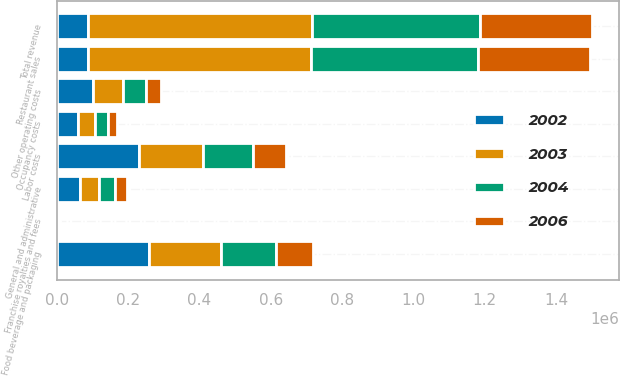Convert chart to OTSL. <chart><loc_0><loc_0><loc_500><loc_500><stacked_bar_chart><ecel><fcel>Restaurant sales<fcel>Franchise royalties and fees<fcel>Total revenue<fcel>Food beverage and packaging<fcel>Labor costs<fcel>Occupancy costs<fcel>Other operating costs<fcel>General and administrative<nl><fcel>2002<fcel>88499.5<fcel>3143<fcel>88499.5<fcel>257998<fcel>231134<fcel>58804<fcel>102745<fcel>65284<nl><fcel>2003<fcel>625077<fcel>2618<fcel>627695<fcel>202288<fcel>178721<fcel>47636<fcel>82976<fcel>51964<nl><fcel>2004<fcel>468579<fcel>2142<fcel>470721<fcel>154148<fcel>139494<fcel>36190<fcel>64274<fcel>44837<nl><fcel>2006<fcel>314027<fcel>1493<fcel>315520<fcel>104921<fcel>94023<fcel>25570<fcel>43527<fcel>34189<nl></chart> 